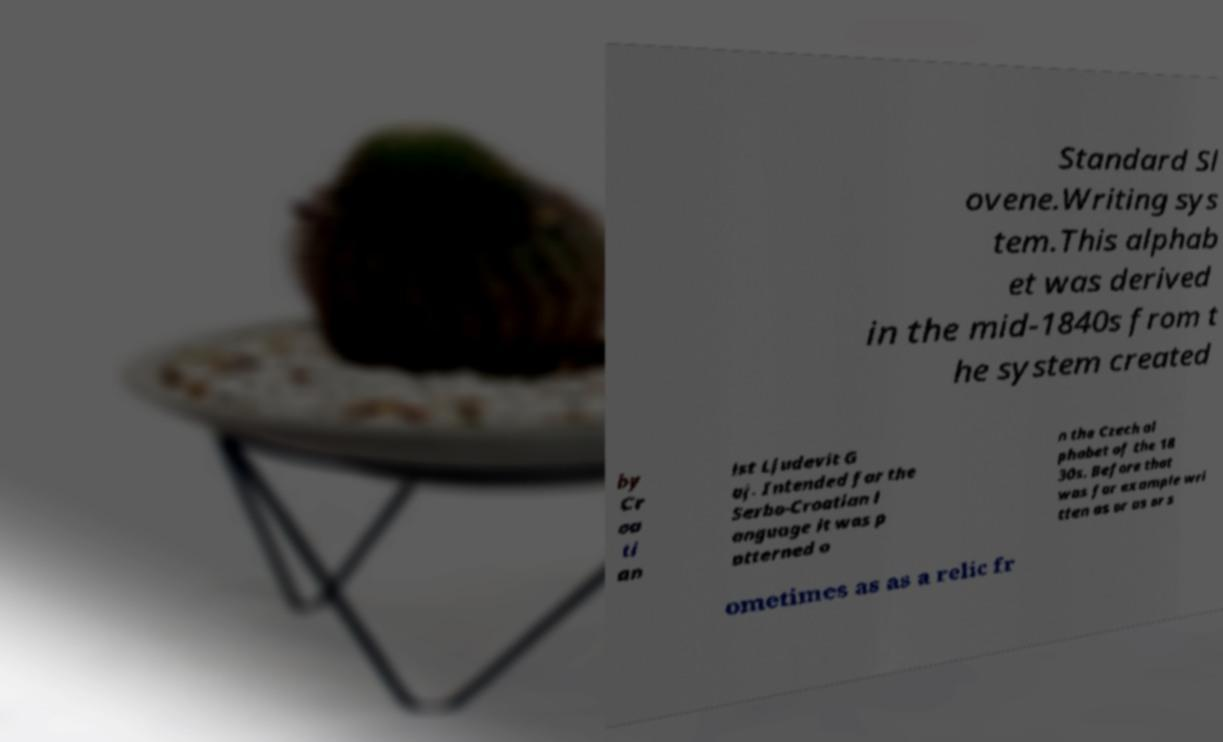Can you read and provide the text displayed in the image?This photo seems to have some interesting text. Can you extract and type it out for me? Standard Sl ovene.Writing sys tem.This alphab et was derived in the mid-1840s from t he system created by Cr oa ti an ist Ljudevit G aj. Intended for the Serbo-Croatian l anguage it was p atterned o n the Czech al phabet of the 18 30s. Before that was for example wri tten as or as or s ometimes as as a relic fr 